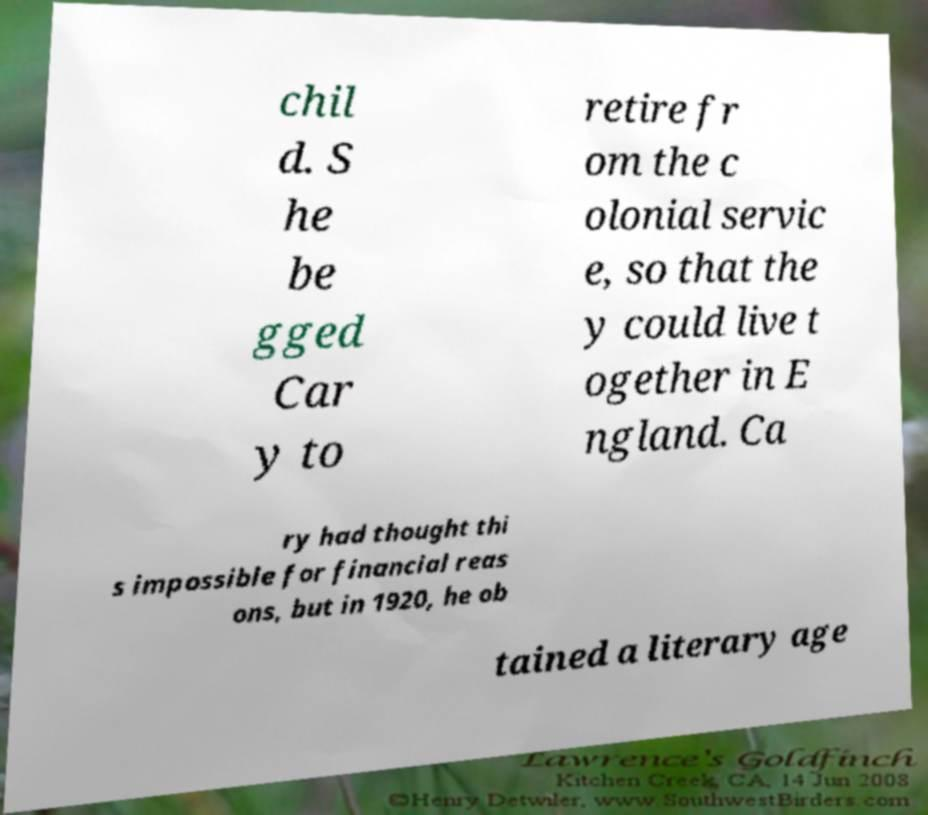Can you accurately transcribe the text from the provided image for me? chil d. S he be gged Car y to retire fr om the c olonial servic e, so that the y could live t ogether in E ngland. Ca ry had thought thi s impossible for financial reas ons, but in 1920, he ob tained a literary age 